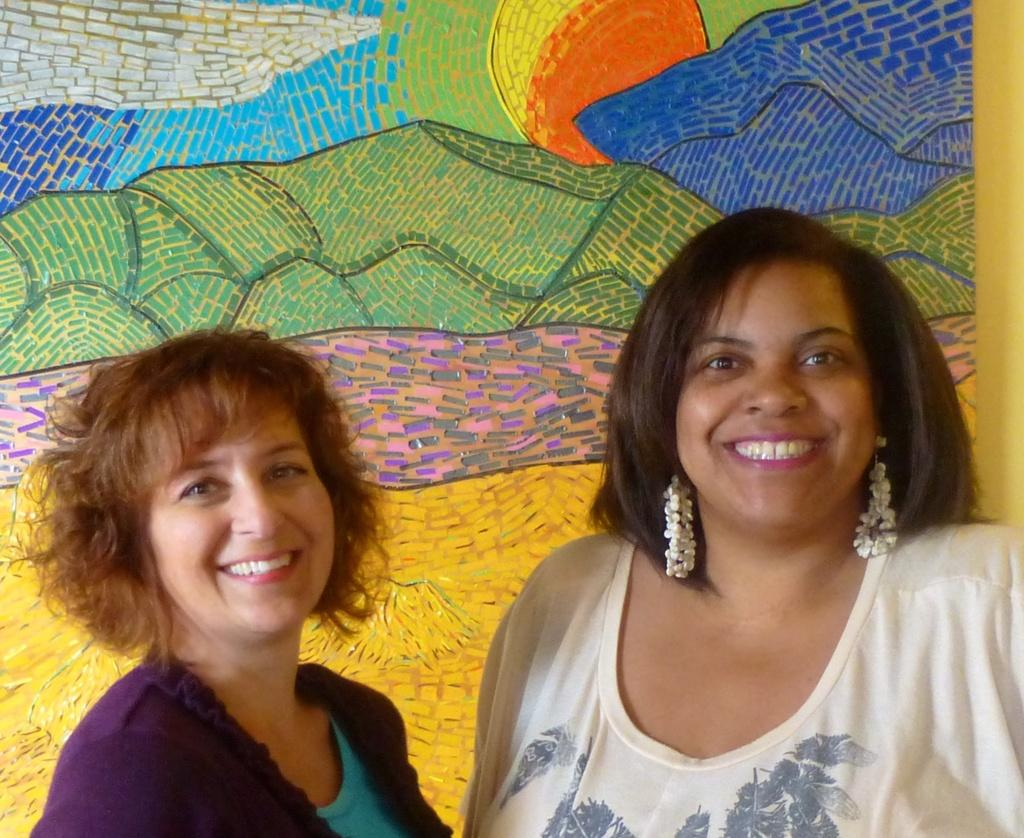How many people are present in the image? There are two women in the image. What can be seen on the wall in the image? There are paintings on a wall in the image. Can you determine the time of day when the image was taken? The image was likely taken during the day, as there is no indication of darkness or artificial lighting. What type of reward is the woman on the left holding in the image? There is no reward visible in the image; the women are not holding any objects. 